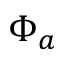<formula> <loc_0><loc_0><loc_500><loc_500>\Phi _ { a }</formula> 